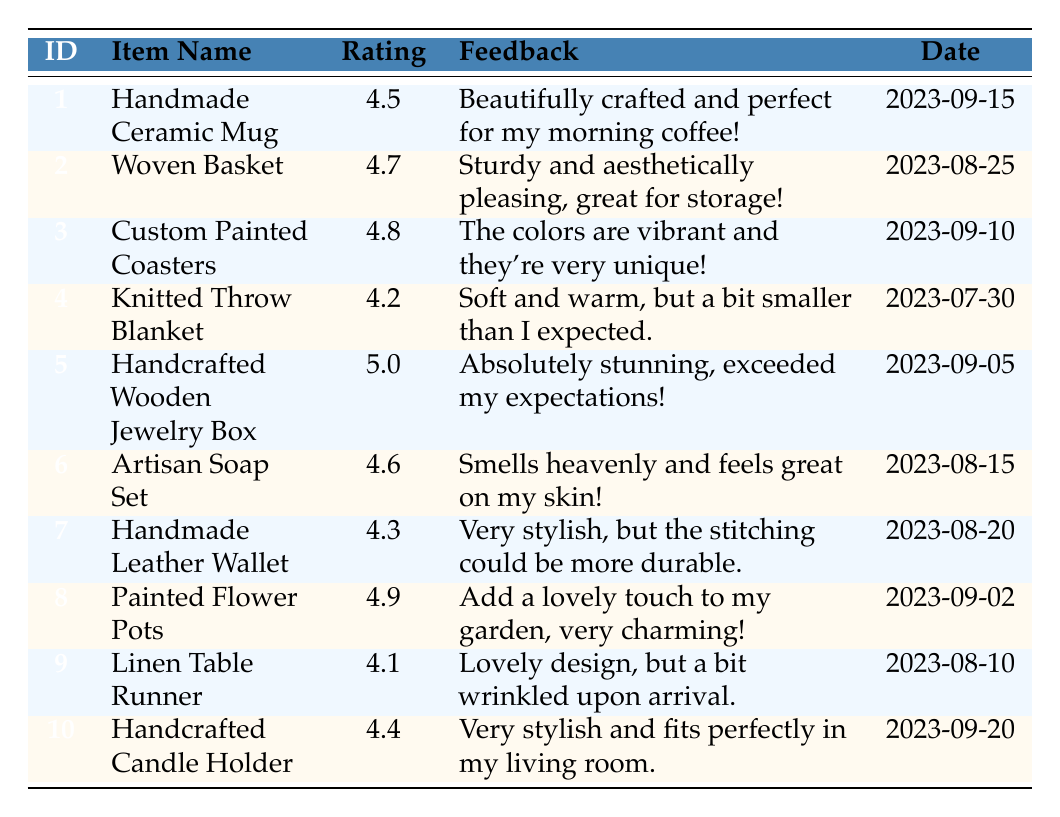What is the highest rating among the craft items? By scanning the Rating column, we identify the ratings for each item. The highest rating is 5.0 for the Handcrafted Wooden Jewelry Box.
Answer: 5.0 What is the feedback for the Painted Flower Pots? Looking at the row for Painted Flower Pots, we find the feedback listed as "Add a lovely touch to my garden, very charming!"
Answer: Add a lovely touch to my garden, very charming! Which item has the lowest rating and what is it? We can observe the ratings and see that the lowest rating is 4.1, and it belongs to the Linen Table Runner.
Answer: Linen Table Runner Is there any item with a rating of 4.9 or higher? By checking the Rating column, we confirm that both the Custom Painted Coasters (4.8) and the Painted Flower Pots (4.9) meet this criterion, so yes, there are items above 4.9.
Answer: Yes What is the average rating among all items listed? To calculate the average, we first sum the ratings: (4.5 + 4.7 + 4.8 + 4.2 + 5.0 + 4.6 + 4.3 + 4.9 + 4.1 + 4.4) = 46.5. There are 10 items, thus the average rating is 46.5 / 10 = 4.65.
Answer: 4.65 How many items have a rating below 4.5? Reviewing the ratings, we find that the ratings below 4.5 are 4.2 (Knitted Throw Blanket) and 4.1 (Linen Table Runner), amounting to 2 items.
Answer: 2 Does the Handcrafted Wooden Jewelry Box have positive feedback? Checking the feedback for the Handcrafted Wooden Jewelry Box, it states "Absolutely stunning, exceeded my expectations!" which indicates positive feedback.
Answer: Yes Which item was purchased most recently? The Purchase Date for all items shows that the most recent date is 2023-09-20 for the Handcrafted Candle Holder.
Answer: Handcrafted Candle Holder What is the difference between the highest and lowest ratings? The highest rating is 5.0 (Handcrafted Wooden Jewelry Box) and the lowest is 4.1 (Linen Table Runner). The difference is 5.0 - 4.1 = 0.9.
Answer: 0.9 